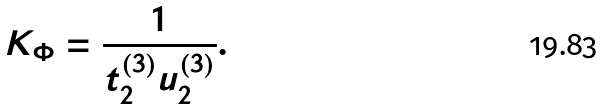Convert formula to latex. <formula><loc_0><loc_0><loc_500><loc_500>K _ { \Phi } = \frac { 1 } { t _ { 2 } ^ { ( 3 ) } u _ { 2 } ^ { ( 3 ) } } .</formula> 